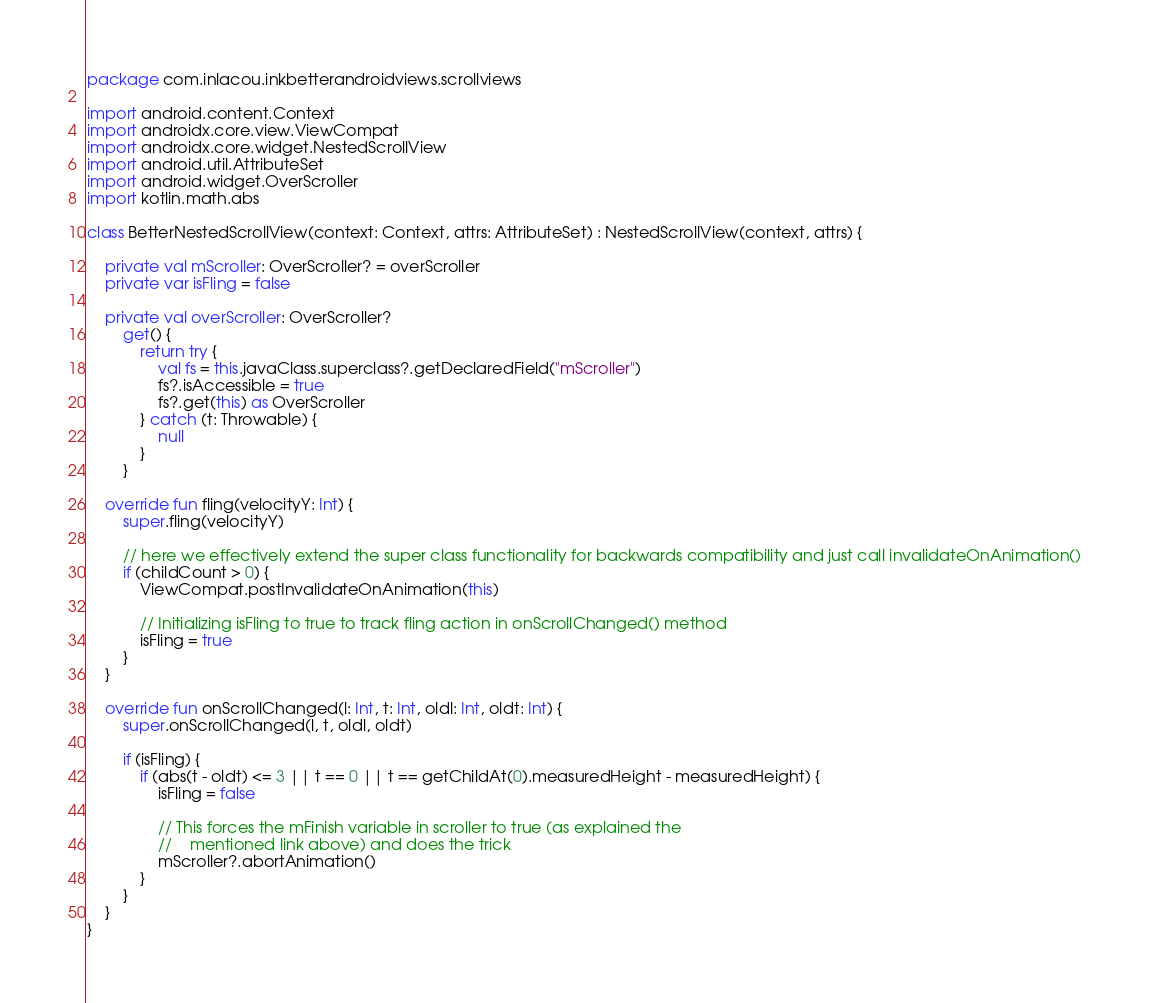<code> <loc_0><loc_0><loc_500><loc_500><_Kotlin_>package com.inlacou.inkbetterandroidviews.scrollviews

import android.content.Context
import androidx.core.view.ViewCompat
import androidx.core.widget.NestedScrollView
import android.util.AttributeSet
import android.widget.OverScroller
import kotlin.math.abs

class BetterNestedScrollView(context: Context, attrs: AttributeSet) : NestedScrollView(context, attrs) {

	private val mScroller: OverScroller? = overScroller
	private var isFling = false

	private val overScroller: OverScroller?
		get() {
			return try {
				val fs = this.javaClass.superclass?.getDeclaredField("mScroller")
				fs?.isAccessible = true
				fs?.get(this) as OverScroller
			} catch (t: Throwable) {
				null
			}
		}

	override fun fling(velocityY: Int) {
		super.fling(velocityY)

		// here we effectively extend the super class functionality for backwards compatibility and just call invalidateOnAnimation()
		if (childCount > 0) {
			ViewCompat.postInvalidateOnAnimation(this)

			// Initializing isFling to true to track fling action in onScrollChanged() method
			isFling = true
		}
	}

	override fun onScrollChanged(l: Int, t: Int, oldl: Int, oldt: Int) {
		super.onScrollChanged(l, t, oldl, oldt)

		if (isFling) {
			if (abs(t - oldt) <= 3 || t == 0 || t == getChildAt(0).measuredHeight - measuredHeight) {
				isFling = false

				// This forces the mFinish variable in scroller to true (as explained the
				//    mentioned link above) and does the trick
				mScroller?.abortAnimation()
			}
		}
	}
}</code> 